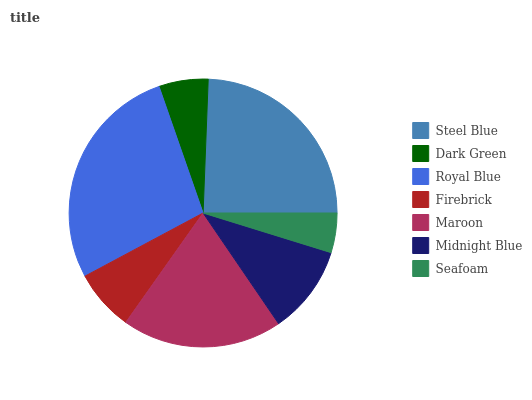Is Seafoam the minimum?
Answer yes or no. Yes. Is Royal Blue the maximum?
Answer yes or no. Yes. Is Dark Green the minimum?
Answer yes or no. No. Is Dark Green the maximum?
Answer yes or no. No. Is Steel Blue greater than Dark Green?
Answer yes or no. Yes. Is Dark Green less than Steel Blue?
Answer yes or no. Yes. Is Dark Green greater than Steel Blue?
Answer yes or no. No. Is Steel Blue less than Dark Green?
Answer yes or no. No. Is Midnight Blue the high median?
Answer yes or no. Yes. Is Midnight Blue the low median?
Answer yes or no. Yes. Is Seafoam the high median?
Answer yes or no. No. Is Steel Blue the low median?
Answer yes or no. No. 